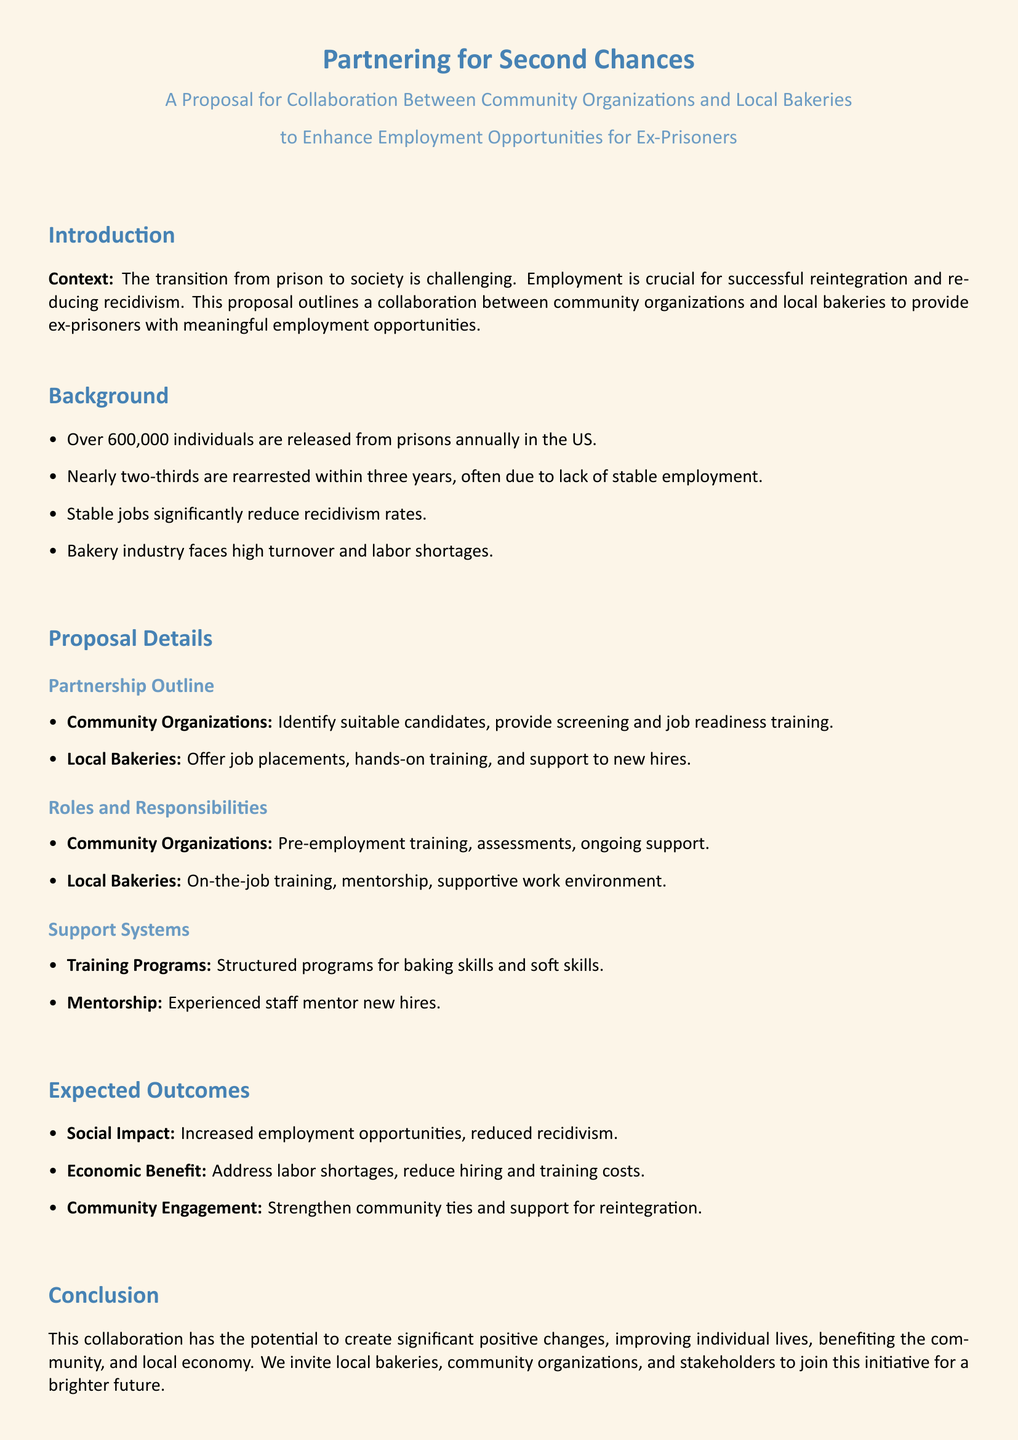What is the main goal of the proposal? The main goal is to provide ex-prisoners with meaningful employment opportunities through collaboration with local bakeries.
Answer: meaningful employment opportunities How many individuals are released from prisons annually in the US? The document states that over 600,000 individuals are released from prisons annually in the US.
Answer: 600,000 What percentage of released individuals are rearrested within three years? The document indicates that nearly two-thirds of released individuals are rearrested within three years.
Answer: two-thirds What is one of the main expected outcomes of the proposal? One expected outcome is reduced recidivism as a result of increased employment opportunities.
Answer: reduced recidivism Who is responsible for providing pre-employment training? Community organizations are responsible for providing pre-employment training.
Answer: Community Organizations What type of training do local bakeries offer? Local bakeries offer on-the-job training to new hires.
Answer: on-the-job training What issue does the bakery industry face according to the document? The bakery industry faces high turnover and labor shortages.
Answer: high turnover and labor shortages What will experienced staff do in the proposed support systems? Experienced staff will mentor new hires in the proposed support systems.
Answer: mentor new hires 